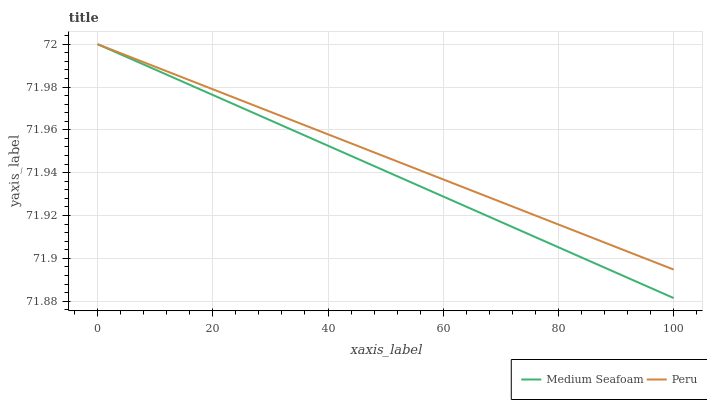Does Medium Seafoam have the minimum area under the curve?
Answer yes or no. Yes. Does Peru have the maximum area under the curve?
Answer yes or no. Yes. Does Peru have the minimum area under the curve?
Answer yes or no. No. Is Medium Seafoam the smoothest?
Answer yes or no. Yes. Is Peru the roughest?
Answer yes or no. Yes. Is Peru the smoothest?
Answer yes or no. No. Does Medium Seafoam have the lowest value?
Answer yes or no. Yes. Does Peru have the lowest value?
Answer yes or no. No. Does Peru have the highest value?
Answer yes or no. Yes. Does Medium Seafoam intersect Peru?
Answer yes or no. Yes. Is Medium Seafoam less than Peru?
Answer yes or no. No. Is Medium Seafoam greater than Peru?
Answer yes or no. No. 